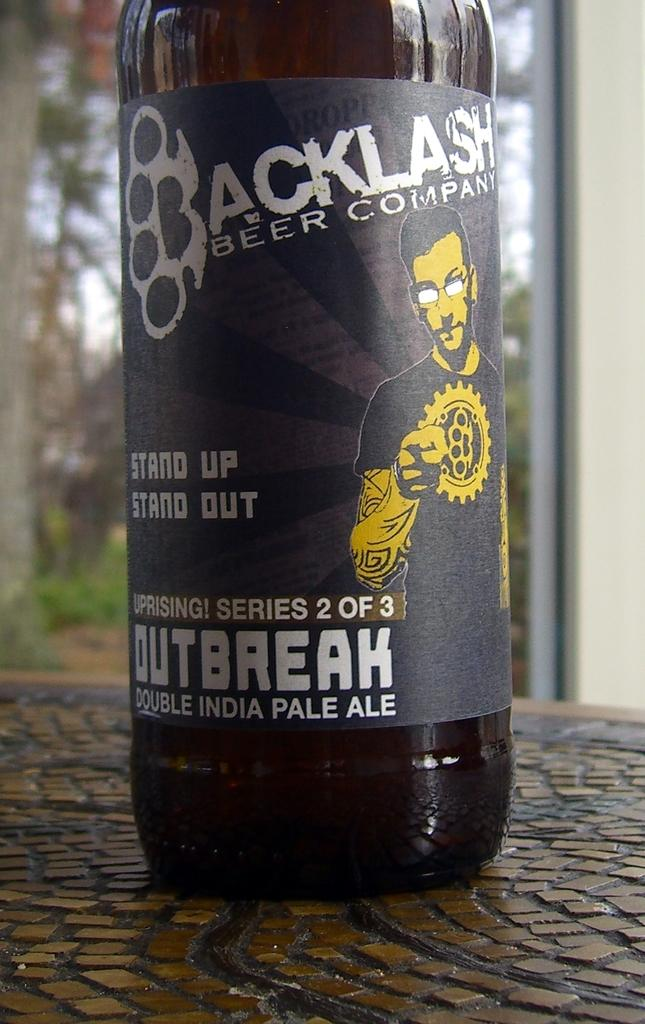What is the main object in the image? There is a bottle with a label in the image. Can you describe the label on the bottle? The bottle has a label attached to it. What is the bottle placed on? The bottle is placed on an object. How would you describe the background of the image? The background of the image appears blurry. How many grandfathers are visible in the image? There are no grandfathers present in the image. What number is written on the label of the bottle? The provided facts do not mention any numbers on the label of the bottle. 